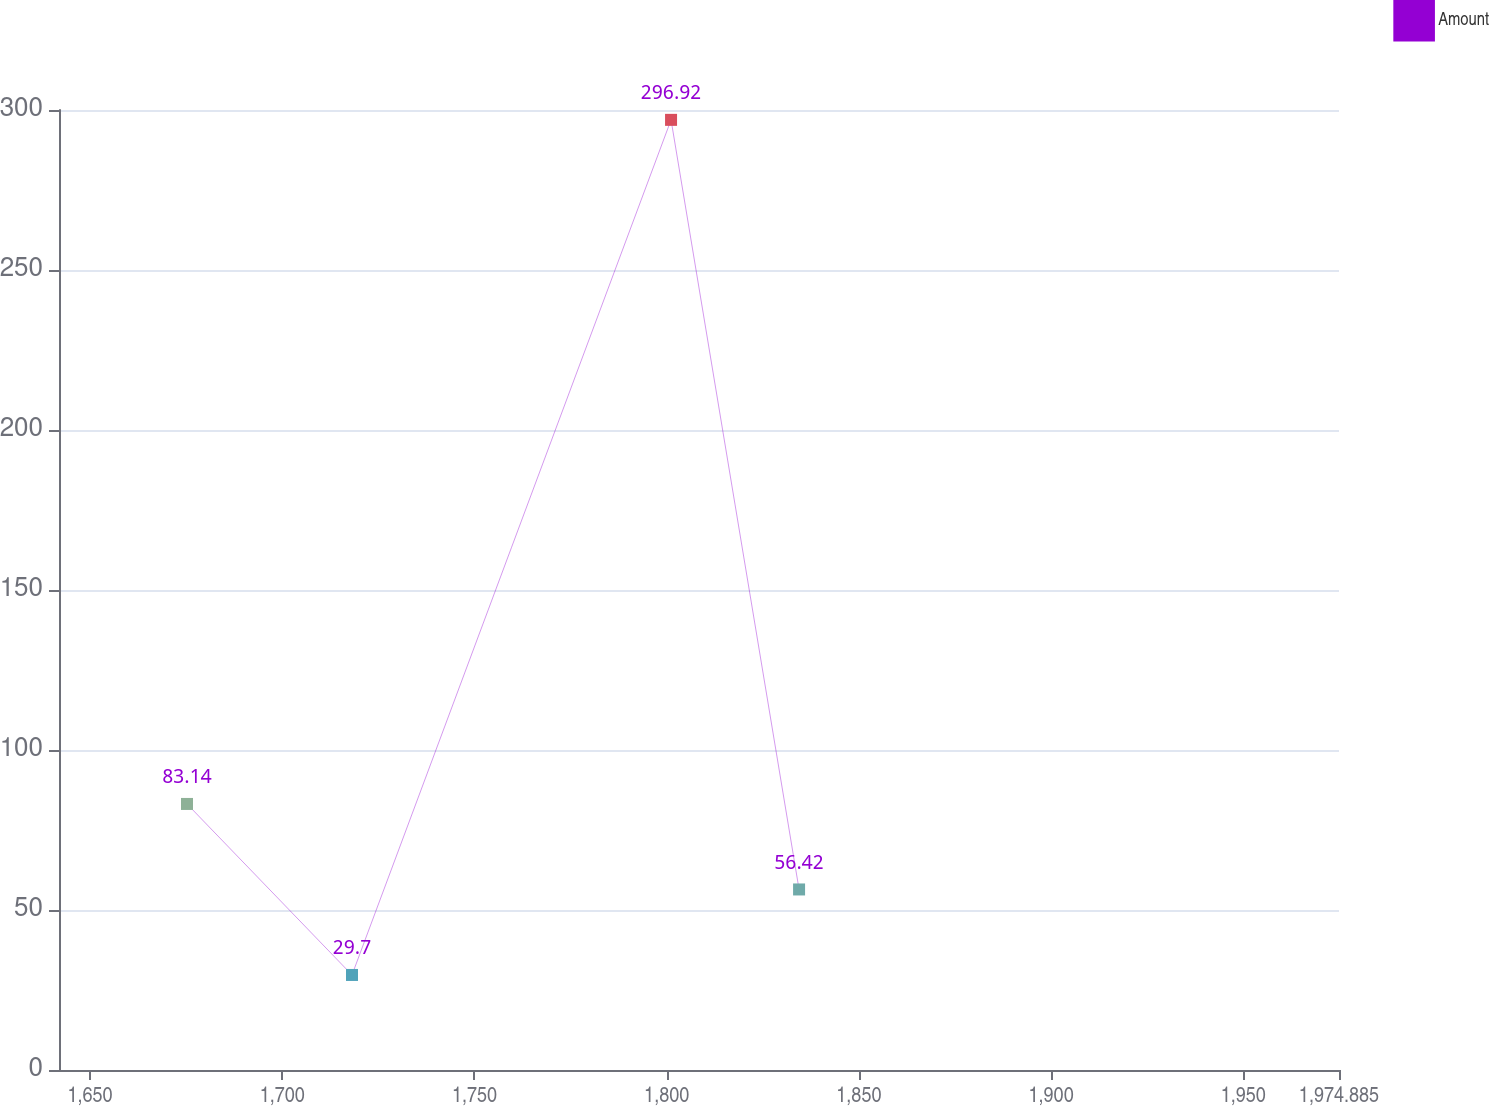<chart> <loc_0><loc_0><loc_500><loc_500><line_chart><ecel><fcel>Amount<nl><fcel>1675.23<fcel>83.14<nl><fcel>1718.15<fcel>29.7<nl><fcel>1801.14<fcel>296.92<nl><fcel>1834.44<fcel>56.42<nl><fcel>2008.18<fcel>157.54<nl></chart> 